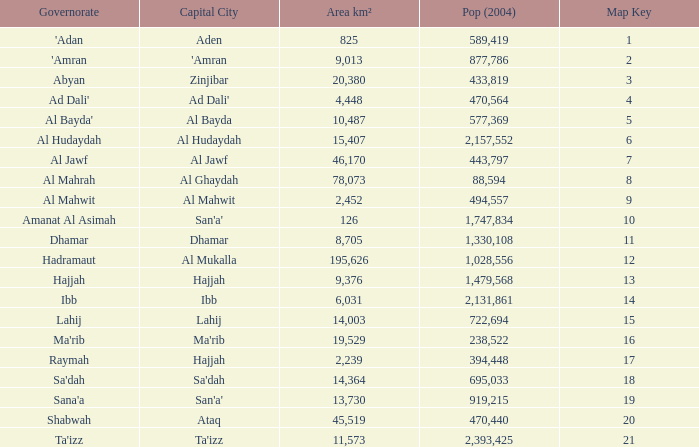Would you mind parsing the complete table? {'header': ['Governorate', 'Capital City', 'Area km²', 'Pop (2004)', 'Map Key'], 'rows': [["'Adan", 'Aden', '825', '589,419', '1'], ["'Amran", "'Amran", '9,013', '877,786', '2'], ['Abyan', 'Zinjibar', '20,380', '433,819', '3'], ["Ad Dali'", "Ad Dali'", '4,448', '470,564', '4'], ["Al Bayda'", 'Al Bayda', '10,487', '577,369', '5'], ['Al Hudaydah', 'Al Hudaydah', '15,407', '2,157,552', '6'], ['Al Jawf', 'Al Jawf', '46,170', '443,797', '7'], ['Al Mahrah', 'Al Ghaydah', '78,073', '88,594', '8'], ['Al Mahwit', 'Al Mahwit', '2,452', '494,557', '9'], ['Amanat Al Asimah', "San'a'", '126', '1,747,834', '10'], ['Dhamar', 'Dhamar', '8,705', '1,330,108', '11'], ['Hadramaut', 'Al Mukalla', '195,626', '1,028,556', '12'], ['Hajjah', 'Hajjah', '9,376', '1,479,568', '13'], ['Ibb', 'Ibb', '6,031', '2,131,861', '14'], ['Lahij', 'Lahij', '14,003', '722,694', '15'], ["Ma'rib", "Ma'rib", '19,529', '238,522', '16'], ['Raymah', 'Hajjah', '2,239', '394,448', '17'], ["Sa'dah", "Sa'dah", '14,364', '695,033', '18'], ["Sana'a", "San'a'", '13,730', '919,215', '19'], ['Shabwah', 'Ataq', '45,519', '470,440', '20'], ["Ta'izz", "Ta'izz", '11,573', '2,393,425', '21']]} Name the amount of Map Key which has a Pop (2004) smaller than 433,819, and a Capital City of hajjah, and an Area km² smaller than 9,376? Question 1 17.0. 